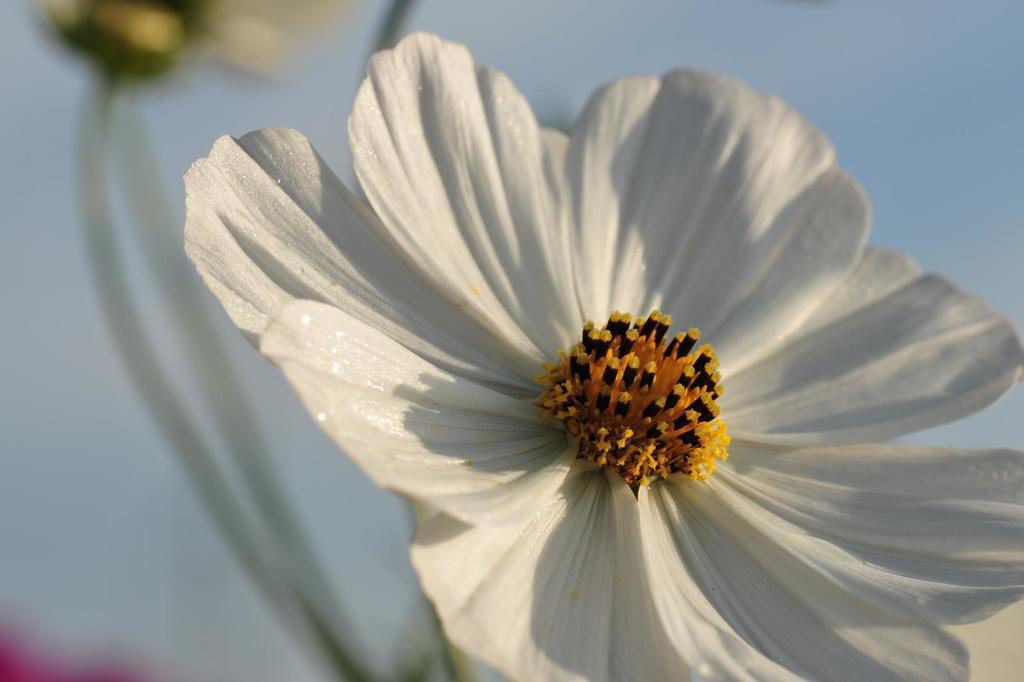In one or two sentences, can you explain what this image depicts? In this picture I can see the white flower. In the back I can see the plant branches and sunflower. In the top right corner I can see the sky and clouds. In the bottom left corner it might be the red flower. 